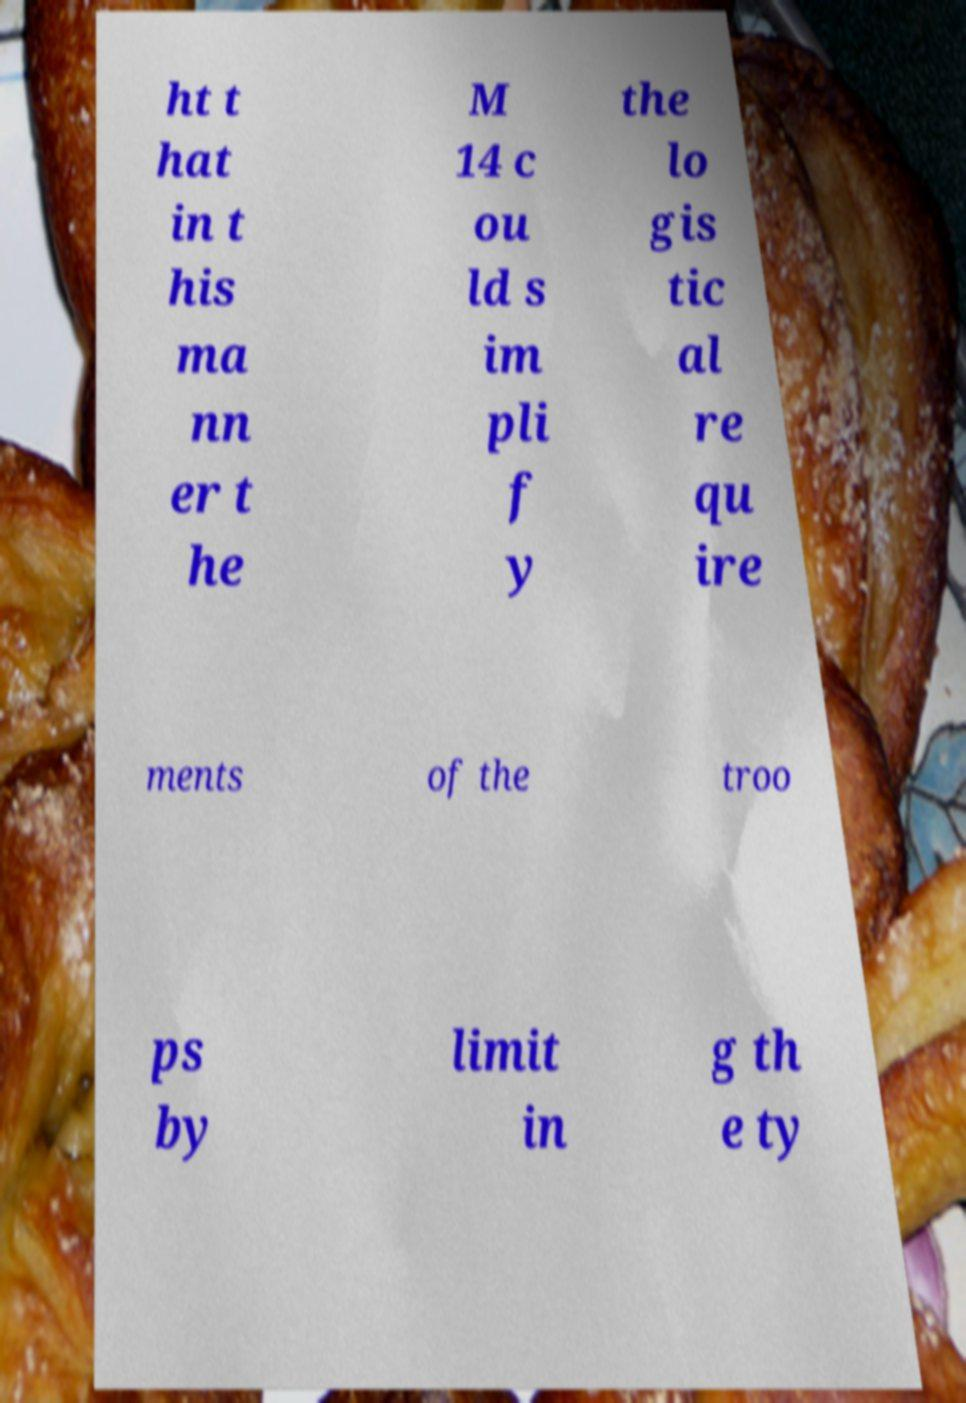What messages or text are displayed in this image? I need them in a readable, typed format. ht t hat in t his ma nn er t he M 14 c ou ld s im pli f y the lo gis tic al re qu ire ments of the troo ps by limit in g th e ty 